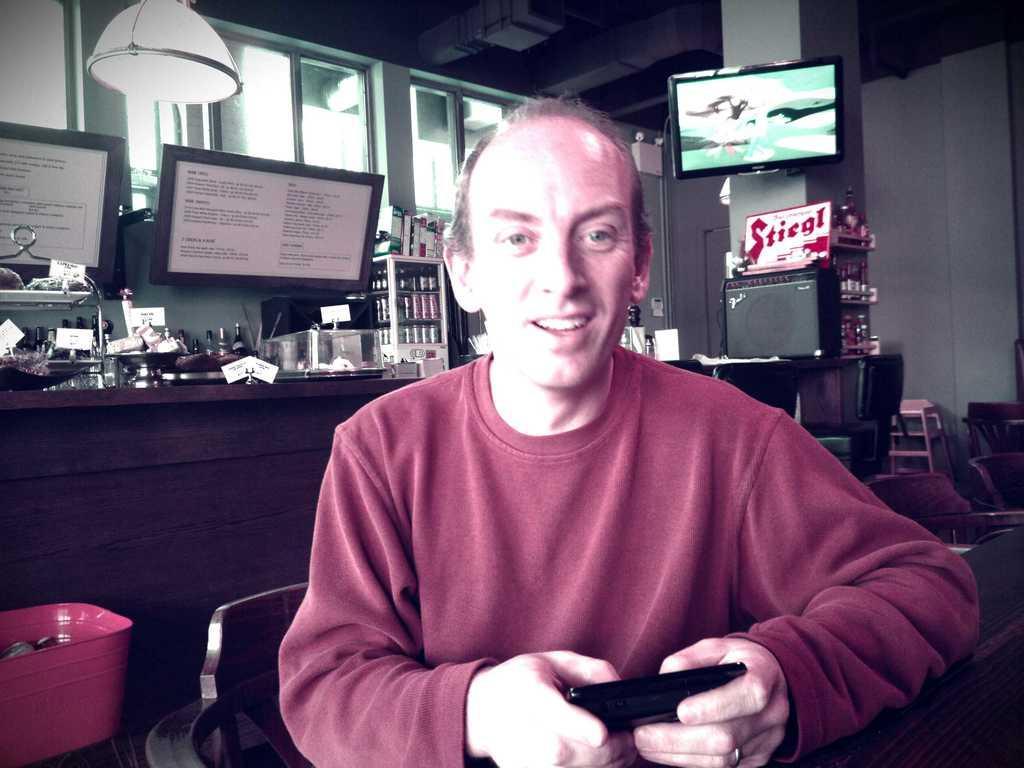Can you describe this image briefly? In this image I see a man who is wearing maroon t-shirt and he is holding a black color thing in his hand and I see that he is sitting on a chair and in the background I see few more chairs over here and I see a TV on this pillar and I see 2 boards over here and I see a light over here and I can also see the windows, few bottles over here and I see many more things and I see the wall and I see a board over here on which there is a word written. 